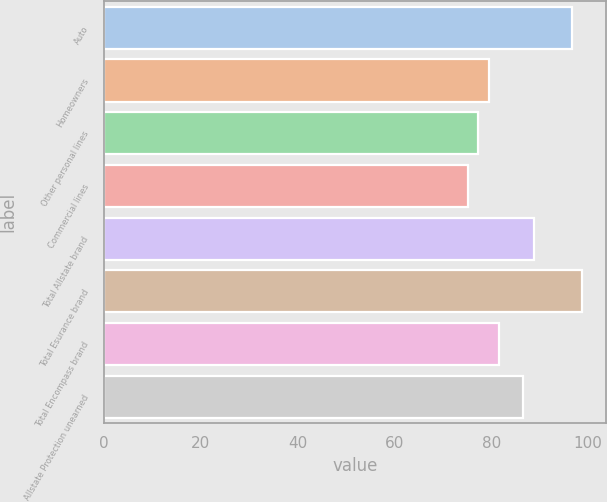<chart> <loc_0><loc_0><loc_500><loc_500><bar_chart><fcel>Auto<fcel>Homeowners<fcel>Other personal lines<fcel>Commercial lines<fcel>Total Allstate brand<fcel>Total Esurance brand<fcel>Total Encompass brand<fcel>Allstate Protection unearned<nl><fcel>96.6<fcel>79.48<fcel>77.34<fcel>75.2<fcel>88.74<fcel>98.74<fcel>81.62<fcel>86.6<nl></chart> 